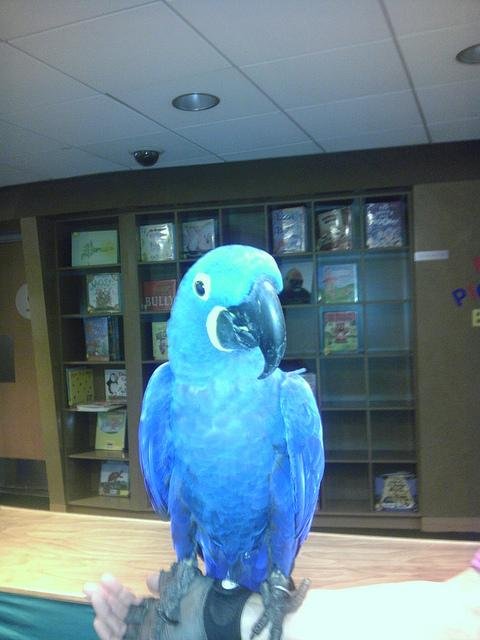Why is the person holding the bird wearing a glove? protection 